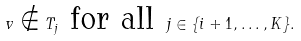Convert formula to latex. <formula><loc_0><loc_0><loc_500><loc_500>v \notin T _ { j } \text { for all } j \in \{ i + 1 , \dots , K \} .</formula> 